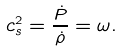Convert formula to latex. <formula><loc_0><loc_0><loc_500><loc_500>c _ { s } ^ { 2 } = \frac { \dot { P } } { \dot { \rho } } = \omega .</formula> 